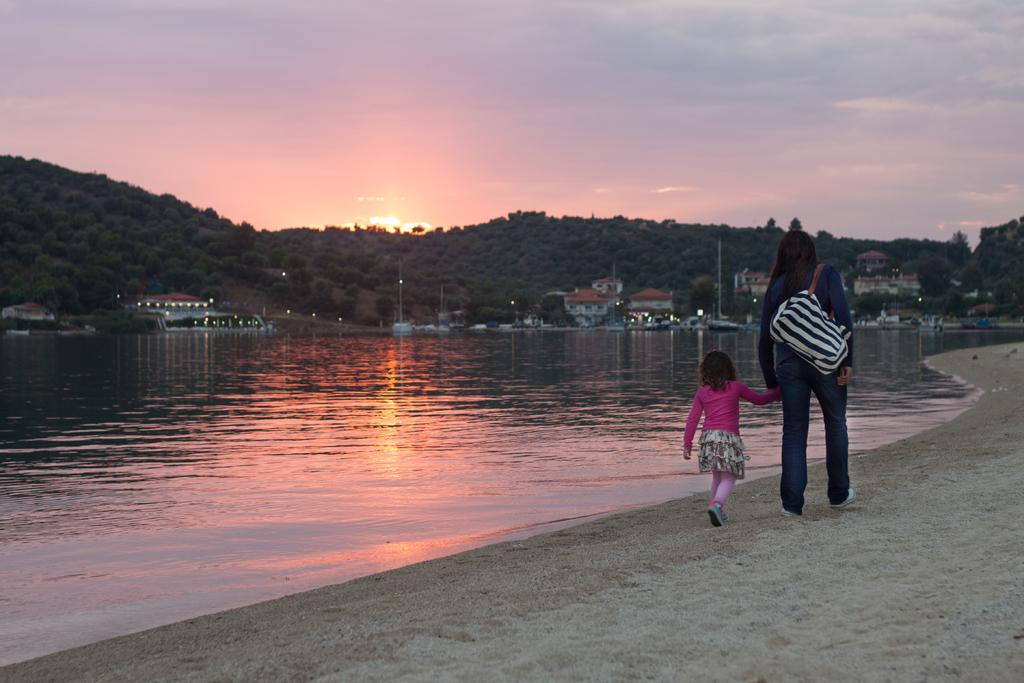Who is present in the image? There is a woman and a child in the image. What are the woman and child wearing? The woman and child are wearing clothes and shoes. What is the woman carrying in the image? The woman is carrying a handbag. What type of environment is depicted in the image? The image contains sand, water, buildings, a pole, trees, and the sky. Can you see any ghosts in the image? There are no ghosts present in the image. What type of canvas is used to create the image? The image is not a painting or on a canvas; it is a photograph. 